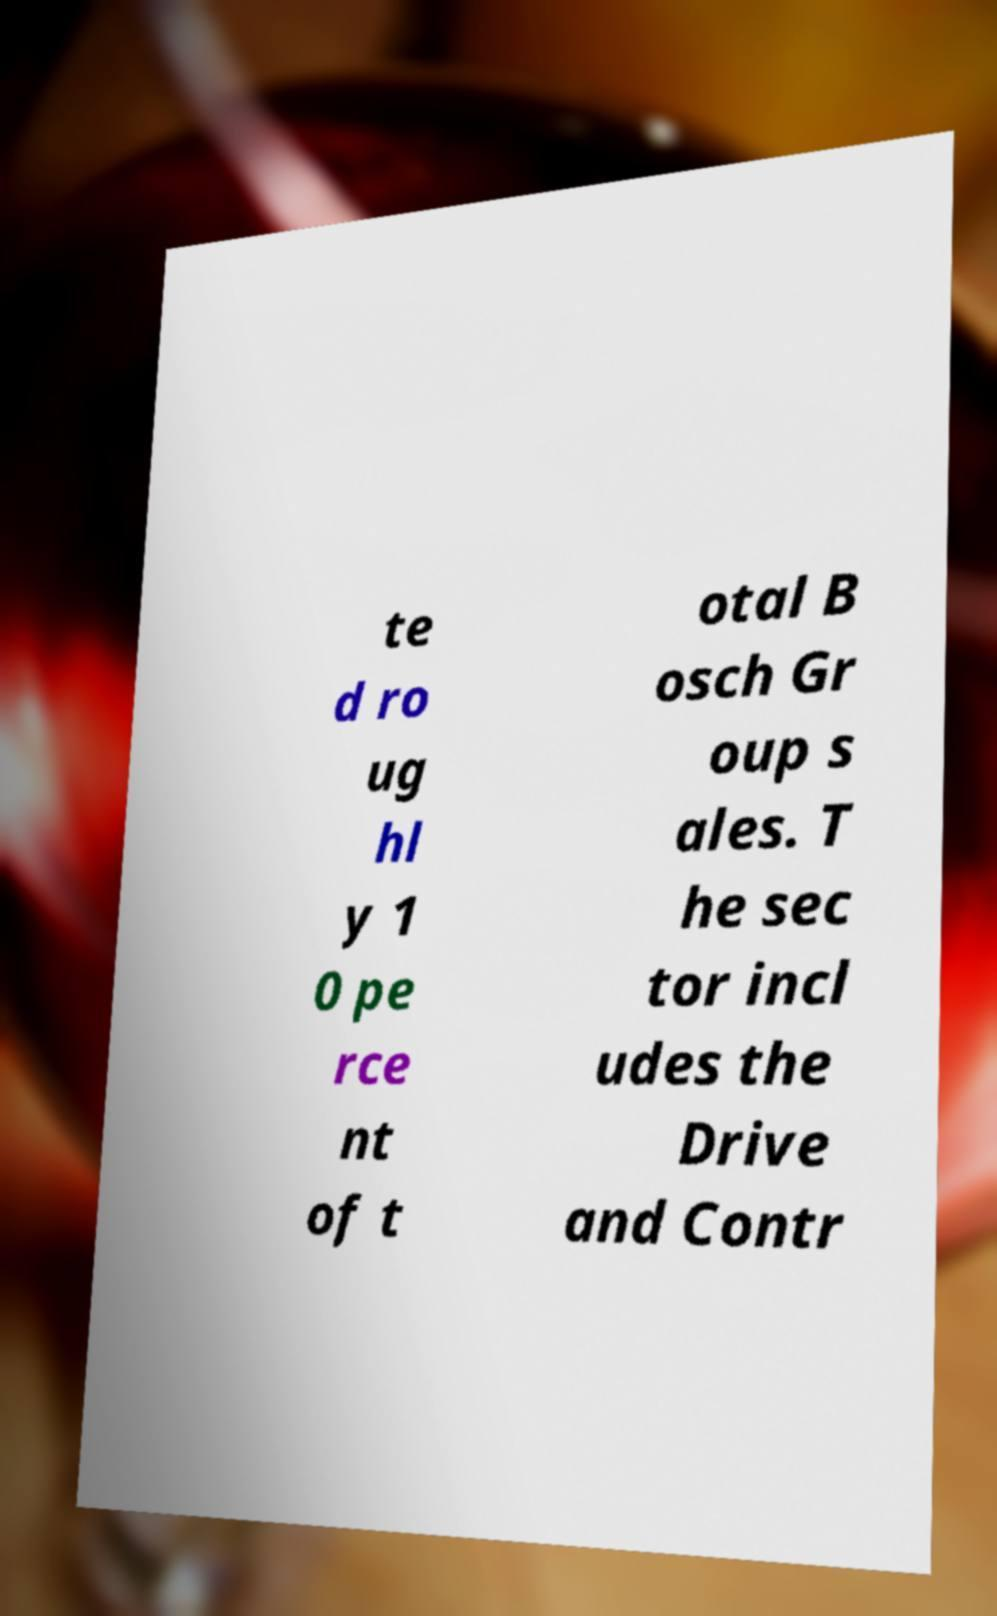For documentation purposes, I need the text within this image transcribed. Could you provide that? te d ro ug hl y 1 0 pe rce nt of t otal B osch Gr oup s ales. T he sec tor incl udes the Drive and Contr 